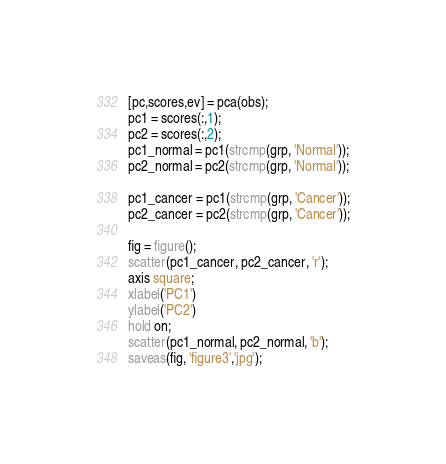<code> <loc_0><loc_0><loc_500><loc_500><_Matlab_>
[pc,scores,ev] = pca(obs);
pc1 = scores(:,1);
pc2 = scores(:,2);
pc1_normal = pc1(strcmp(grp, 'Normal'));
pc2_normal = pc2(strcmp(grp, 'Normal'));

pc1_cancer = pc1(strcmp(grp, 'Cancer'));
pc2_cancer = pc2(strcmp(grp, 'Cancer'));

fig = figure();
scatter(pc1_cancer, pc2_cancer, 'r');
axis square;
xlabel('PC1')
ylabel('PC2')
hold on;
scatter(pc1_normal, pc2_normal, 'b');
saveas(fig, 'figure3','jpg');


</code> 